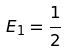<formula> <loc_0><loc_0><loc_500><loc_500>E _ { 1 } = \frac { 1 } { 2 }</formula> 